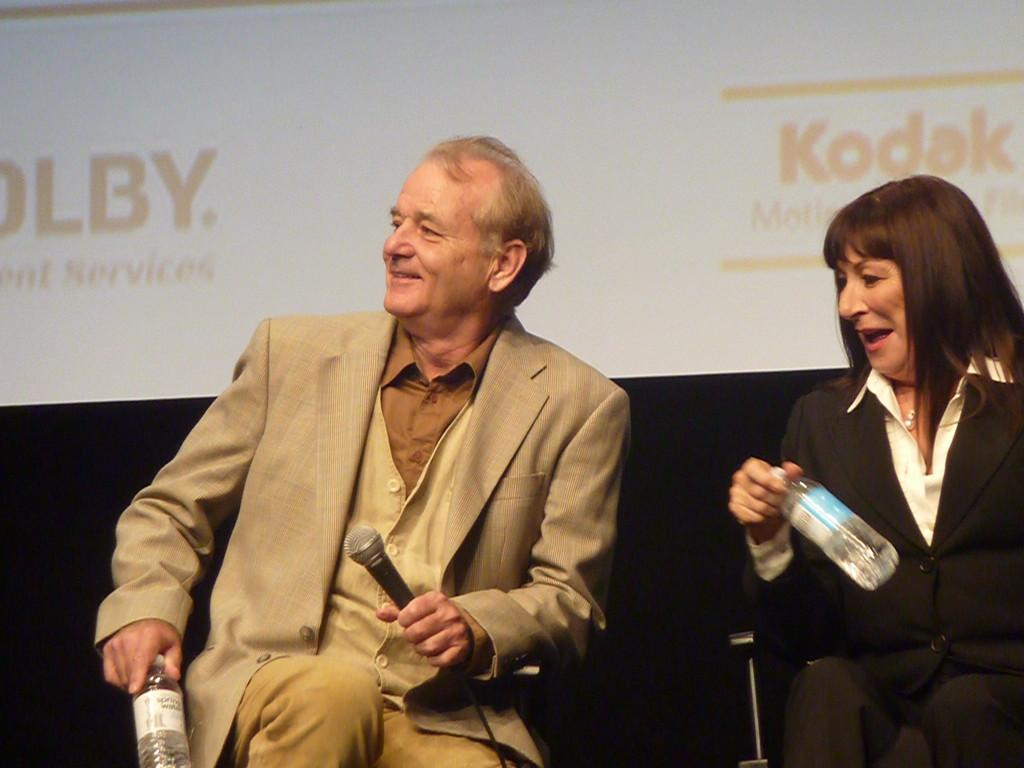How many people are in the image? There are two persons in the image. What are the persons doing in the image? The persons are sitting on chairs. What are the persons holding in their hands? The persons are holding objects in their hands. What can be seen behind the persons in the image? There is a projector screen in the image. What type of leather is visible on the chairs in the image? There is no mention of the chairs being made of leather, nor is any leather visible in the image. 